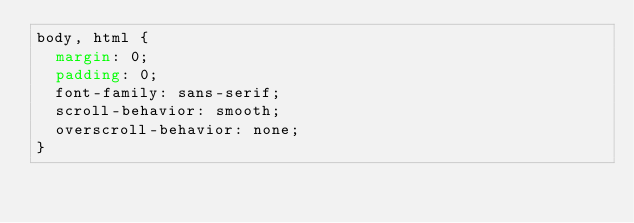<code> <loc_0><loc_0><loc_500><loc_500><_CSS_>body, html {
  margin: 0;
  padding: 0;
  font-family: sans-serif;
  scroll-behavior: smooth;
  overscroll-behavior: none;
}
</code> 